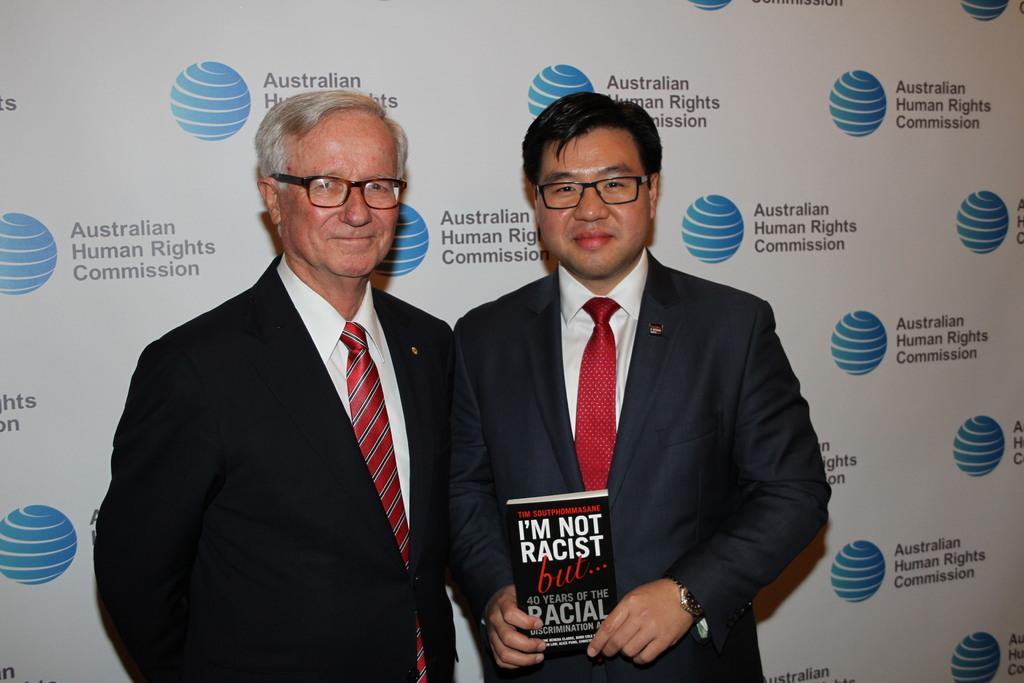Can you describe this image briefly? On the left side, there is a person in a suit, wearing a spectacle, smiling and standing. On the right side, there is another person in a suit, wearing a spectacle, smiling, holding a book and standing. In the background, there is a banner. And the background is white in color. 